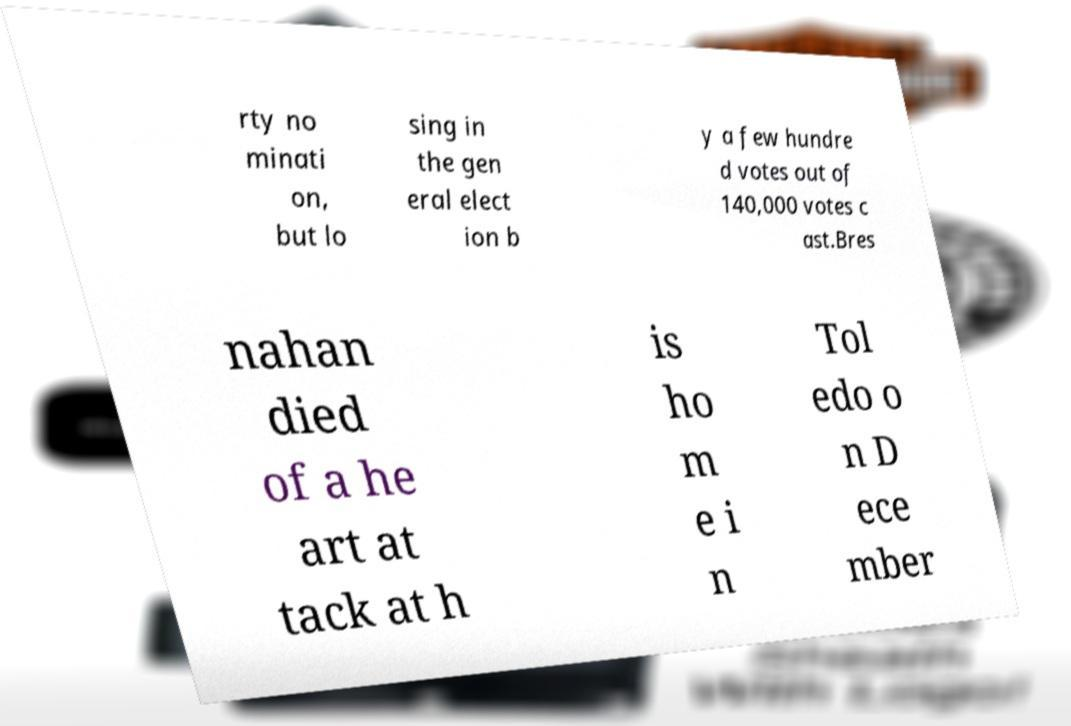Please read and relay the text visible in this image. What does it say? rty no minati on, but lo sing in the gen eral elect ion b y a few hundre d votes out of 140,000 votes c ast.Bres nahan died of a he art at tack at h is ho m e i n Tol edo o n D ece mber 